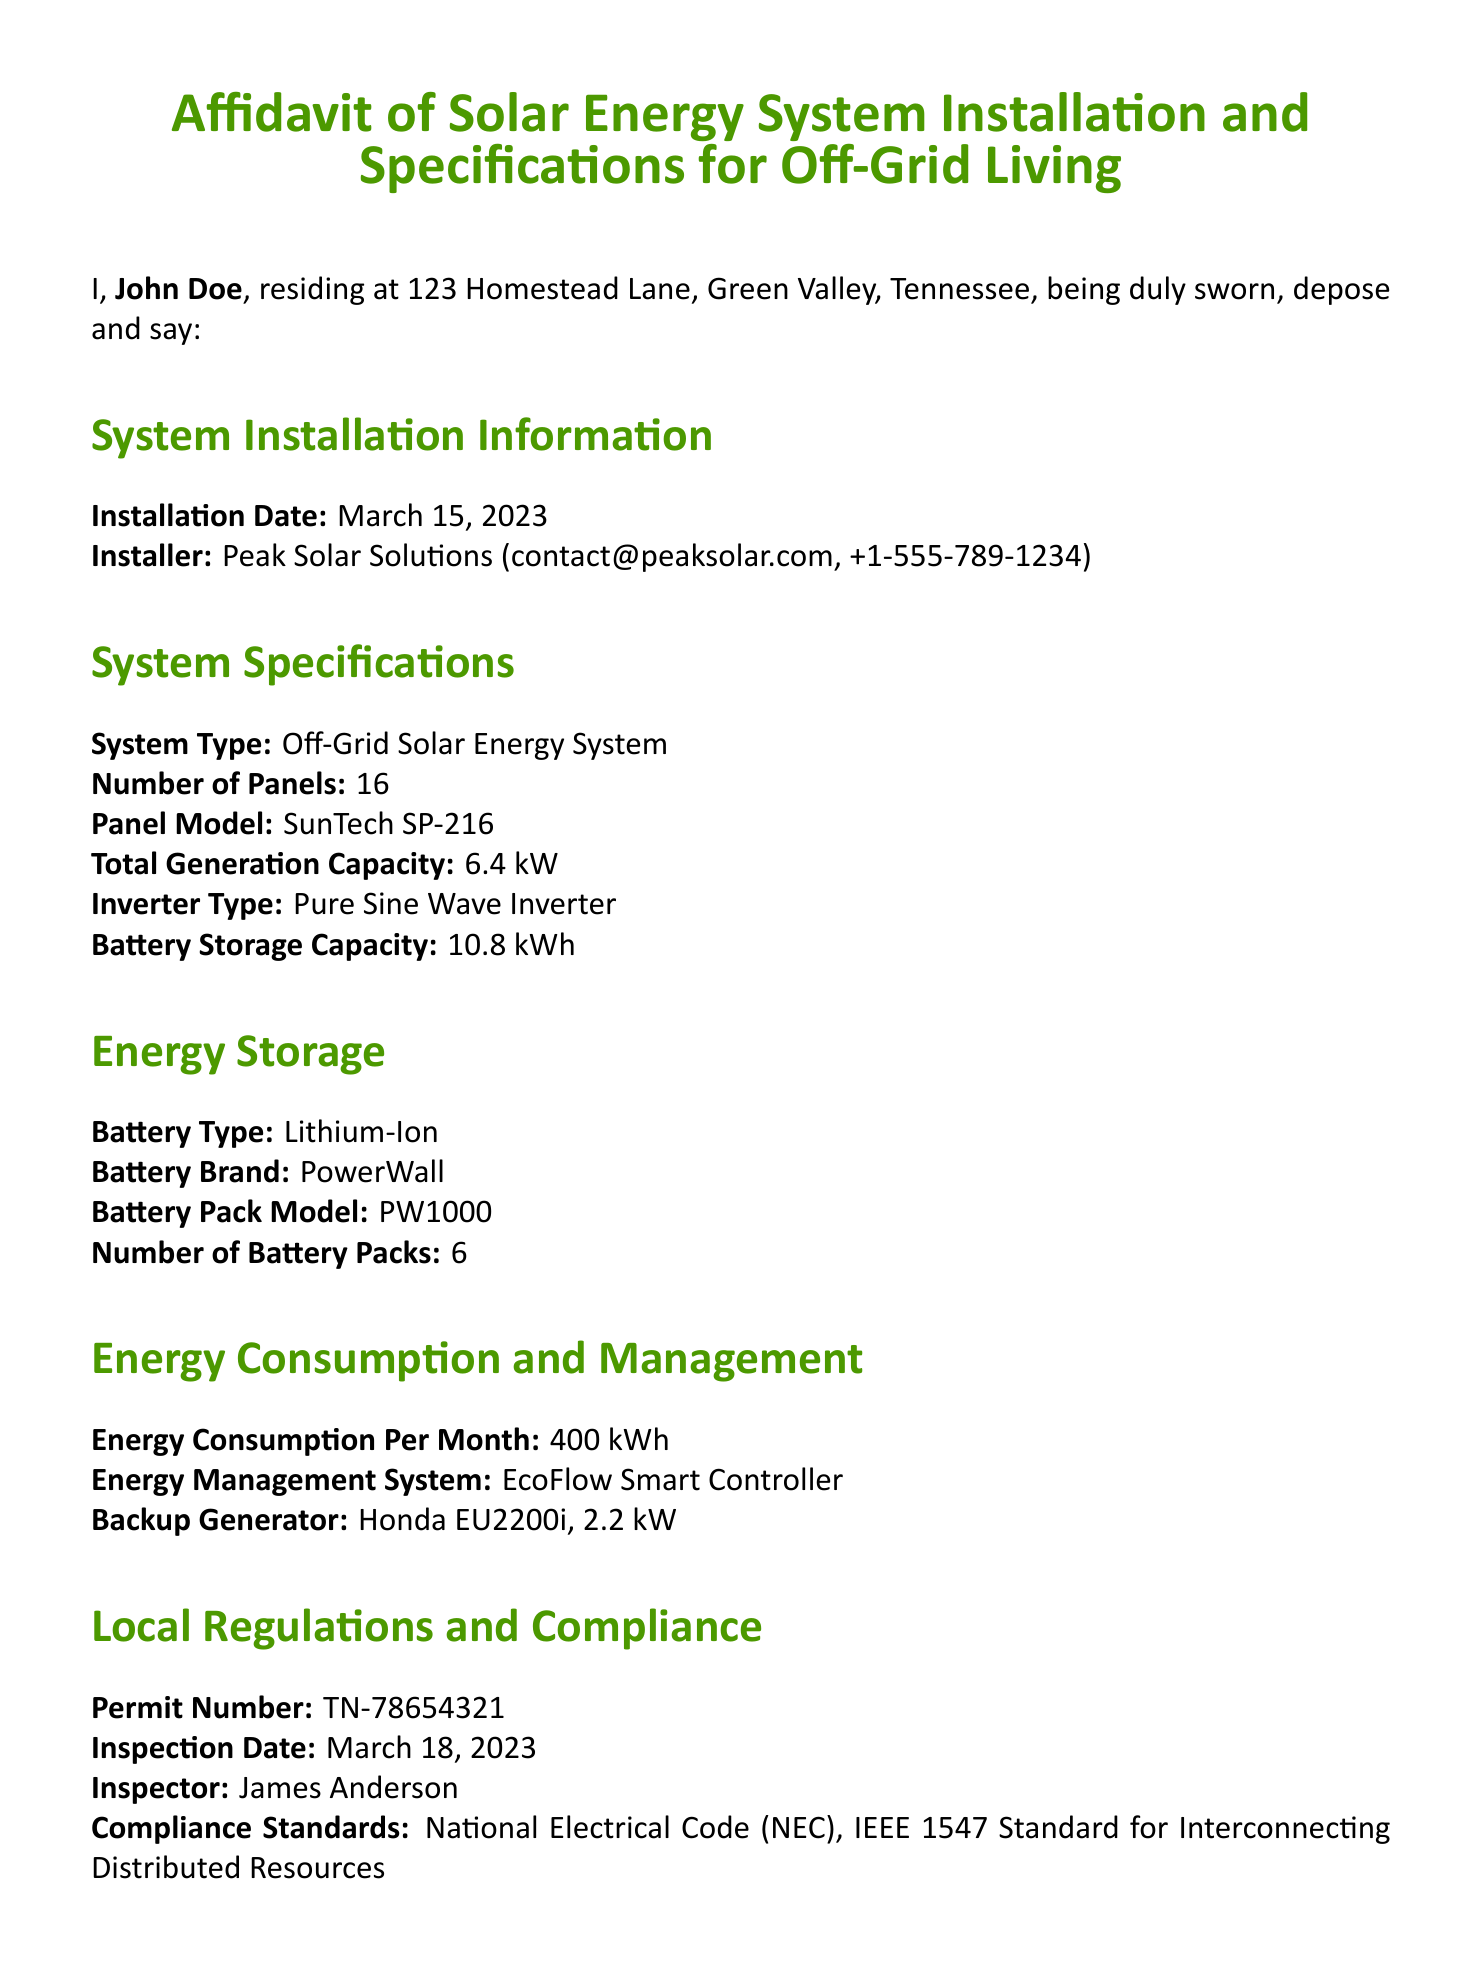What is the installation date? The installation date is clearly stated in the document under "System Installation Information."
Answer: March 15, 2023 Who is the installer? The installer's name and contact information are provided in the "System Installation Information" section.
Answer: Peak Solar Solutions (contact@peaksolar.com, +1-555-789-1234) What is the total generation capacity? The total generation capacity is mentioned under "System Specifications."
Answer: 6.4 kW How many battery packs are used? The number of battery packs is specified in the "Energy Storage" section.
Answer: 6 What is the energy consumption per month? The monthly energy consumption figure is located in the "Energy Consumption and Management" section.
Answer: 400 kWh What is the permit number? The permit number is listed under "Local Regulations and Compliance."
Answer: TN-78654321 Who conducted the inspection? The inspector's name is mentioned in the "Local Regulations and Compliance" section.
Answer: James Anderson What type of battery is used in the system? The battery type is provided in the "Energy Storage" section.
Answer: Lithium-Ion What is the commission expiration date for the notary public? The expiration date for the notary's commission is located towards the end of the document under notary information.
Answer: Dec 31, 2024 